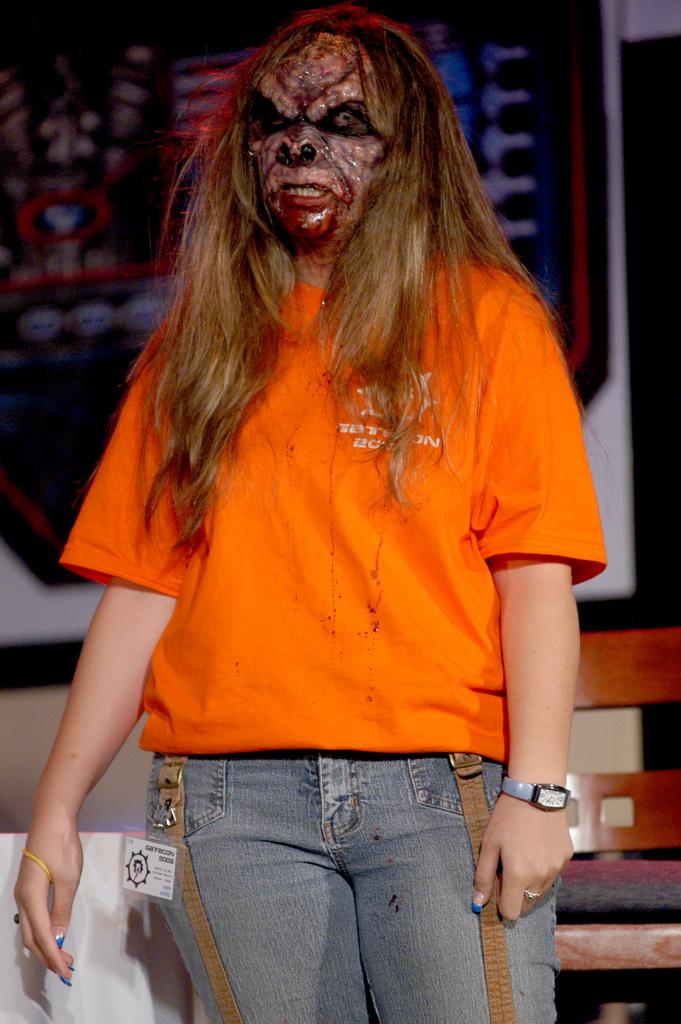What is the primary subject in the image? There is a person standing in the image. Where is the person standing? The person is standing on the floor. What can be seen in the background of the image? There is a chair and a frame attached to the wall in the background of the image. What direction is the person facing in the image? The provided facts do not mention the direction the person is facing, so it cannot be determined from the image. How many sons does the person in the image have? There is no information about the person's family or children in the image, so it cannot be determined. 